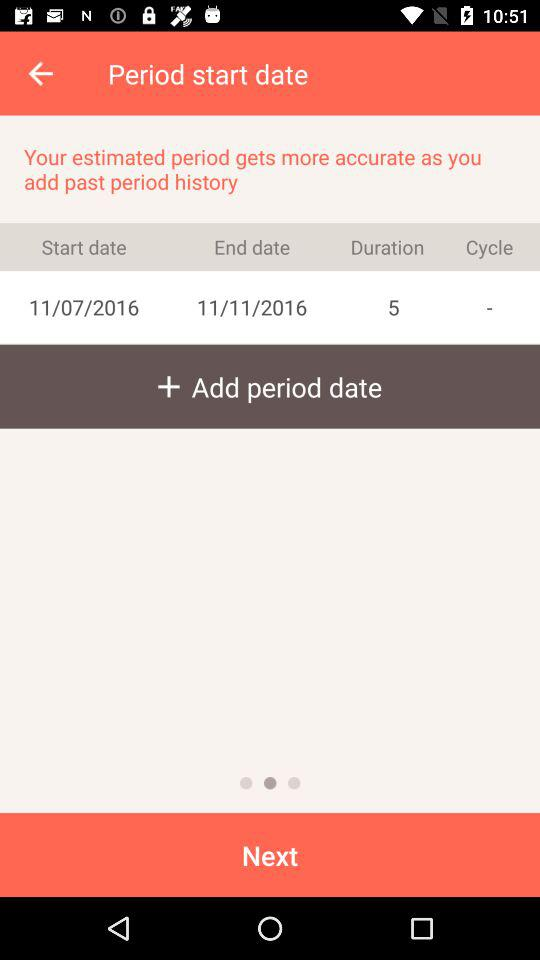What is the start date? The start date is November 7, 2016. 